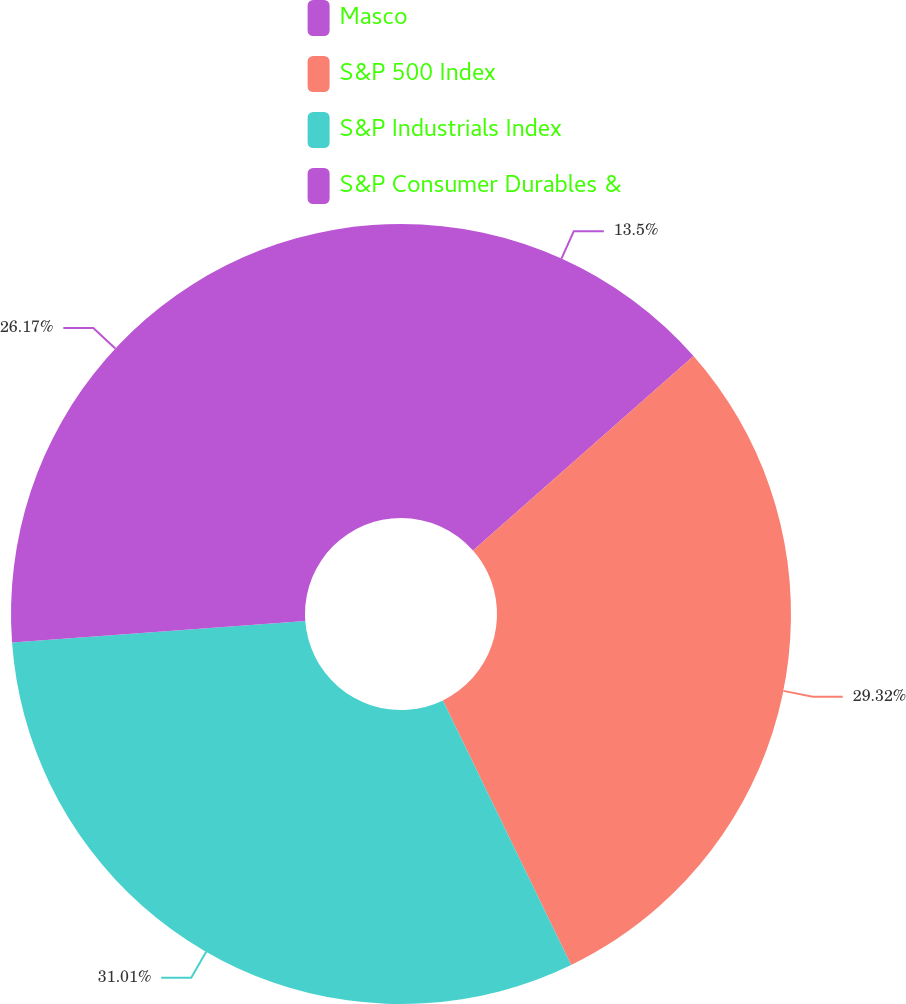Convert chart. <chart><loc_0><loc_0><loc_500><loc_500><pie_chart><fcel>Masco<fcel>S&P 500 Index<fcel>S&P Industrials Index<fcel>S&P Consumer Durables &<nl><fcel>13.5%<fcel>29.32%<fcel>31.02%<fcel>26.17%<nl></chart> 